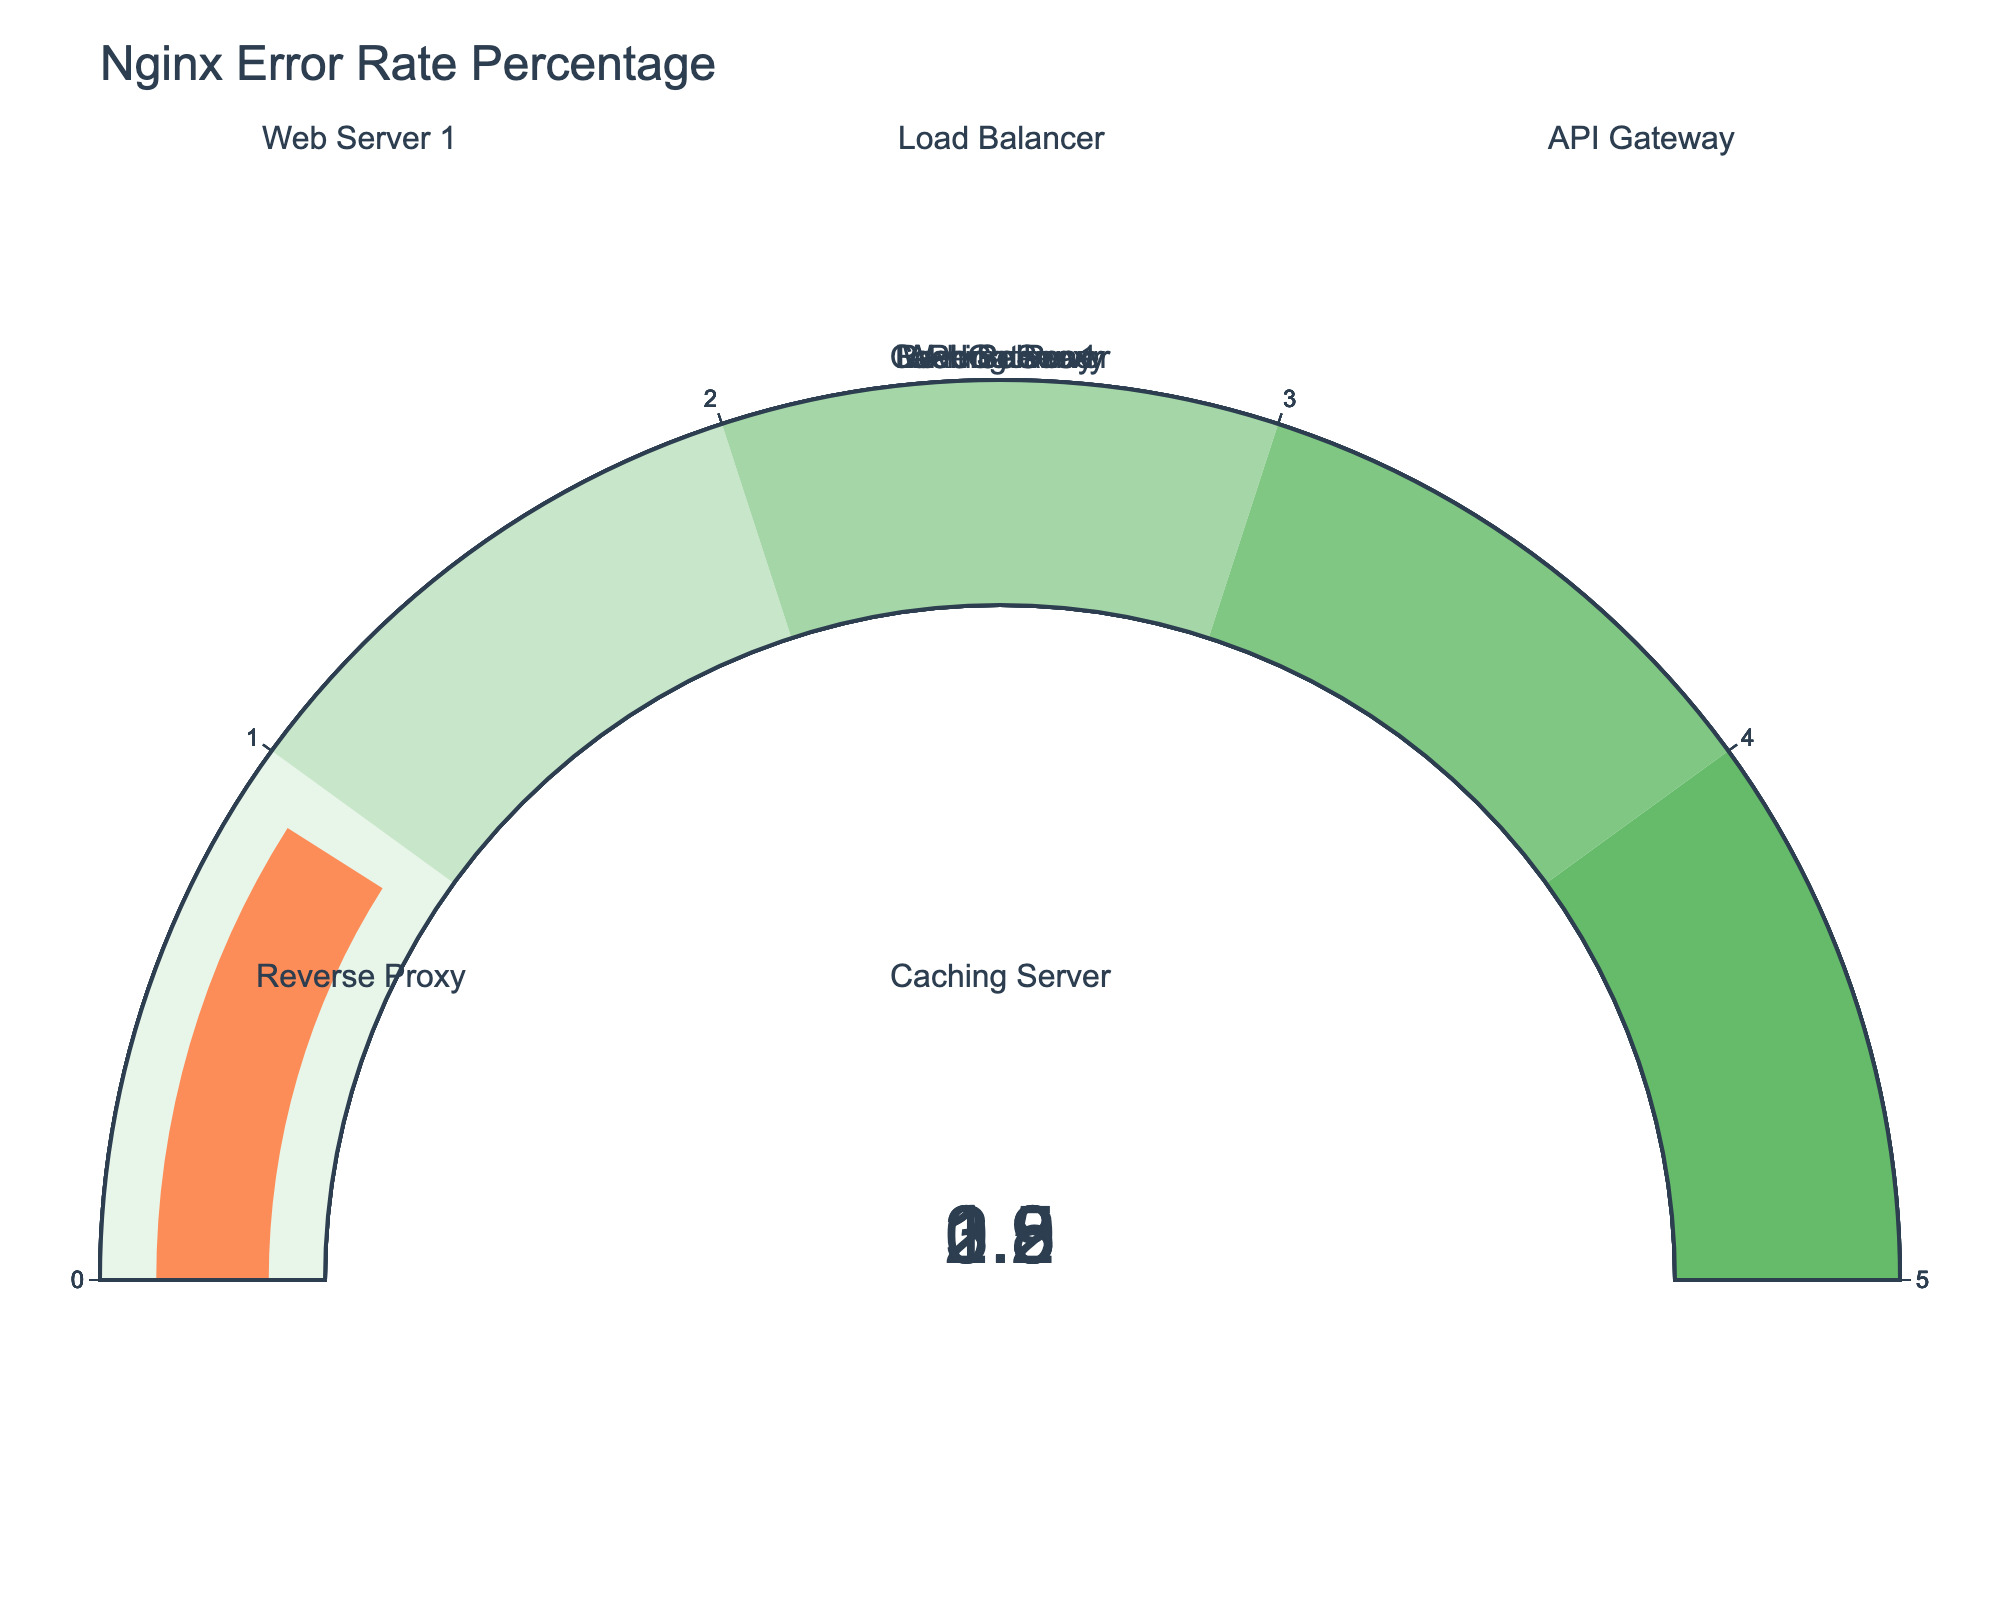Which server has the highest error rate percentage? The server with the highest error rate percentage can be determined by looking at which gauge shows the highest value. The API Gateway shows the highest value at 3.5%.
Answer: API Gateway What is the average error rate percentage across all the servers? Sum the error rates of all servers and then divide by the number of servers: (2.3 + 1.8 + 3.5 + 1.2 + 0.9) / 5 = 9.7 / 5 = 1.94%.
Answer: 1.94% Which server has the lowest error rate percentage? The server with the lowest error rate percentage can be determined by looking at which gauge shows the lowest value. The Caching Server shows the lowest value at 0.9%.
Answer: Caching Server How much higher is the error rate percentage of the API Gateway compared to the Caching Server? Subtract the error rate of the Caching Server from the API Gateway: 3.5% - 0.9% = 2.6%.
Answer: 2.6% Are there any servers with an error rate percentage below 2%? If so, which are they? Look for gauges that show values below 2%. These servers are Load Balancer (1.8%), Reverse Proxy (1.2%), and Caching Server (0.9%).
Answer: Load Balancer, Reverse Proxy, and Caching Server What is the combined error rate percentage of Web Server 1 and API Gateway? Add the error rates of Web Server 1 and API Gateway: 2.3% + 3.5% = 5.8%.
Answer: 5.8% Which server is closest to the average error rate percentage? The average error rate is 1.94%. The server closest to this value is Web Server 1 with 2.3%.
Answer: Web Server 1 How much greater is Web Server 1's error rate percentage compared to Reverse Proxy's? Subtract the error rate of Reverse Proxy from Web Server 1: 2.3% - 1.2% = 1.1%.
Answer: 1.1% What is the total error rate percentage for all the servers combined? Sum all the error rates: 2.3% + 1.8% + 3.5% + 1.2% + 0.9% = 9.7%.
Answer: 9.7% Does any server have an error rate percentage exactly at 1%? Check each gauge to see if any of them show exactly 1%. None of the servers have an error rate percentage exactly at 1%.
Answer: No 